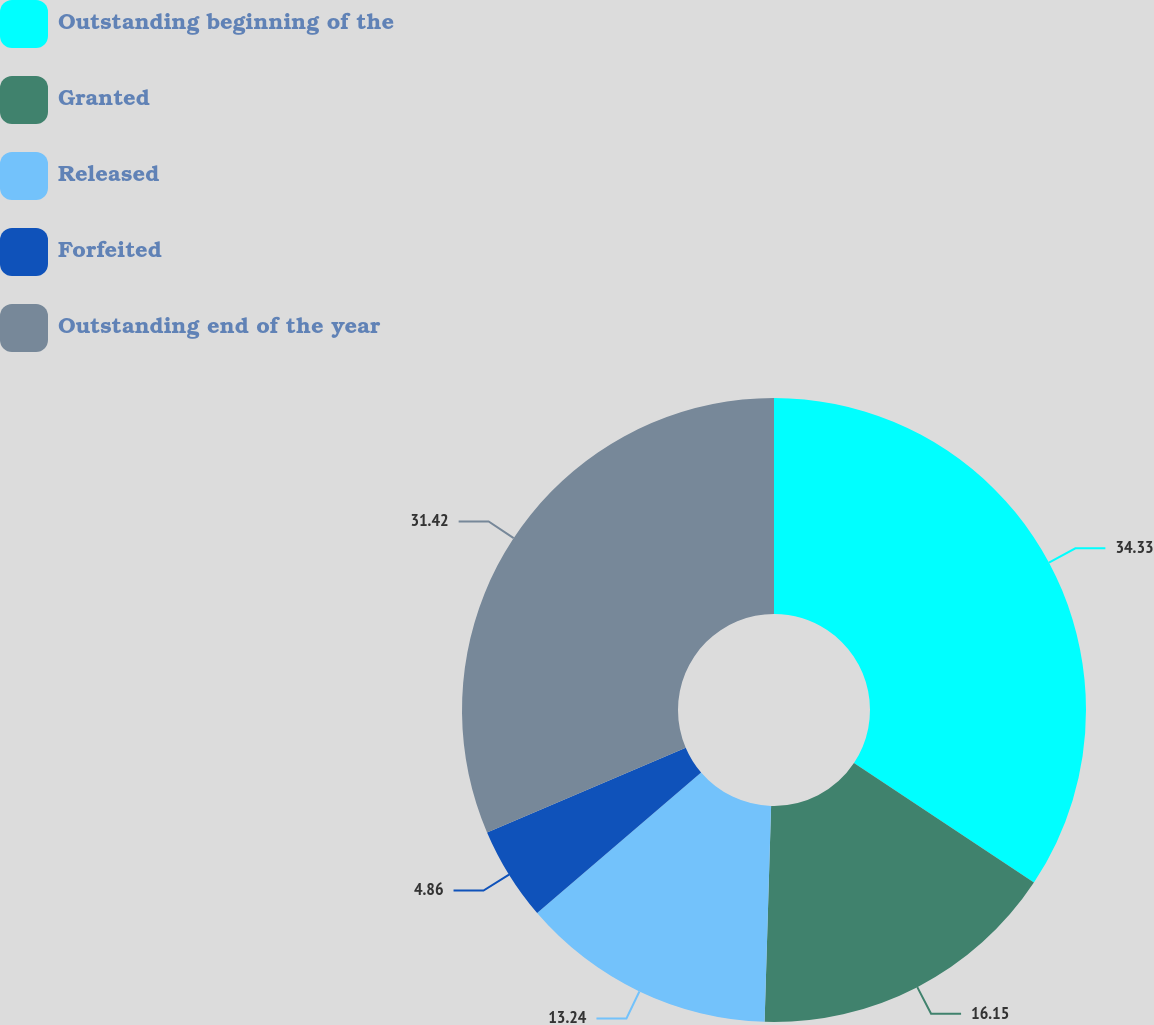Convert chart to OTSL. <chart><loc_0><loc_0><loc_500><loc_500><pie_chart><fcel>Outstanding beginning of the<fcel>Granted<fcel>Released<fcel>Forfeited<fcel>Outstanding end of the year<nl><fcel>34.33%<fcel>16.15%<fcel>13.24%<fcel>4.86%<fcel>31.42%<nl></chart> 